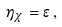Convert formula to latex. <formula><loc_0><loc_0><loc_500><loc_500>\eta _ { \chi } = \epsilon \, ,</formula> 